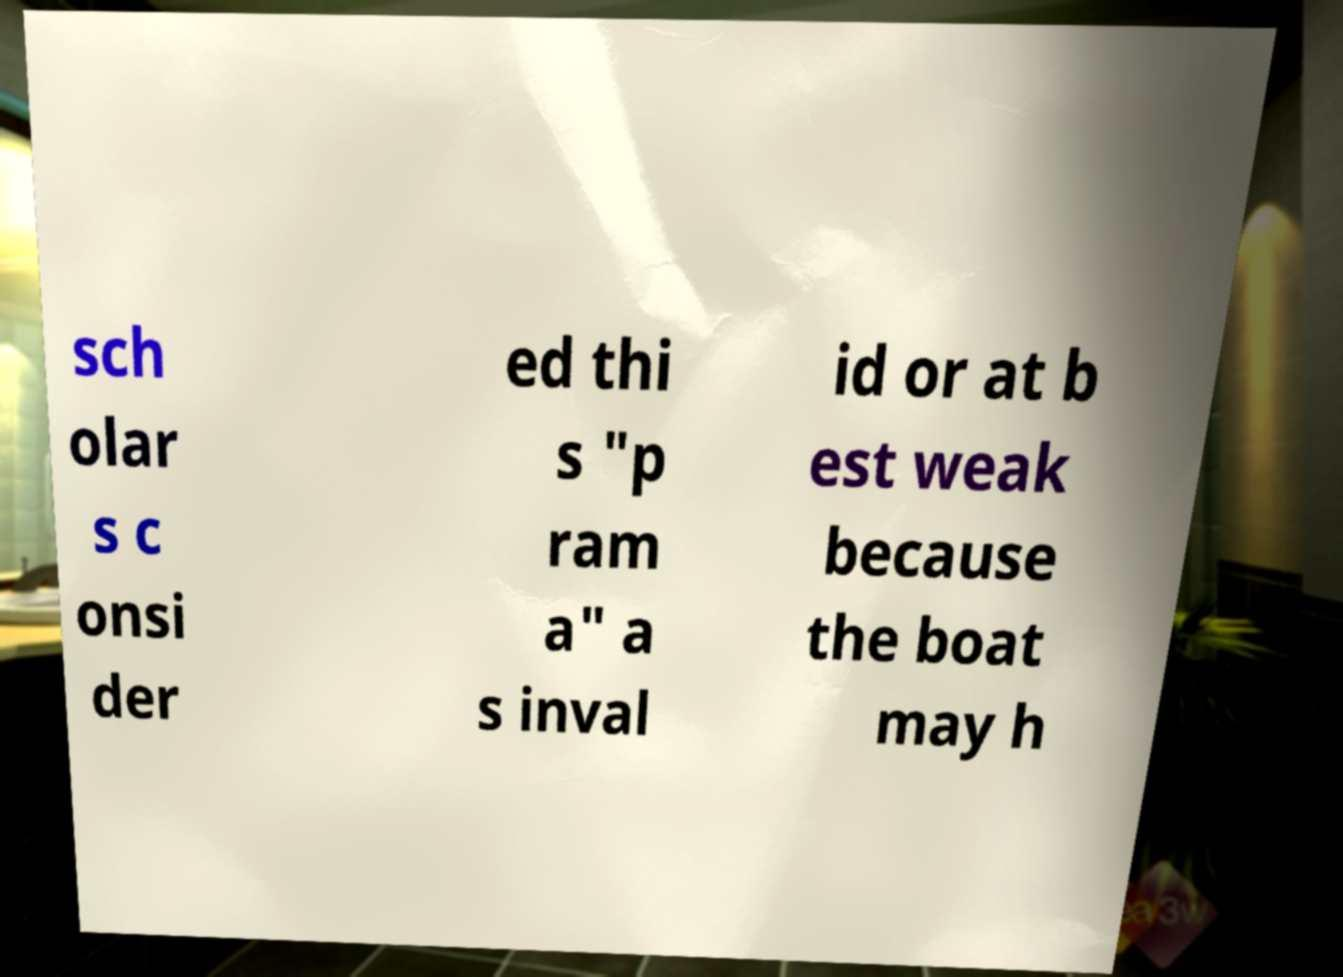For documentation purposes, I need the text within this image transcribed. Could you provide that? sch olar s c onsi der ed thi s "p ram a" a s inval id or at b est weak because the boat may h 